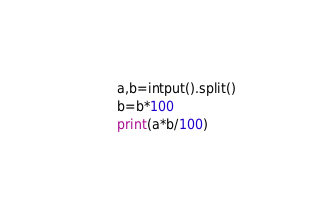<code> <loc_0><loc_0><loc_500><loc_500><_Python_>a,b=intput().split()
b=b*100
print(a*b/100)</code> 